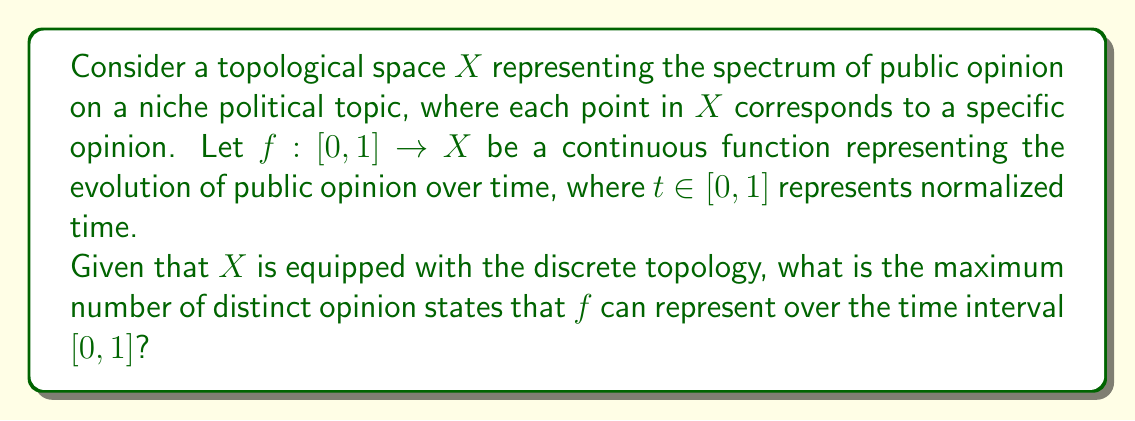Teach me how to tackle this problem. To solve this problem, we need to consider the properties of continuous functions and the discrete topology:

1) In the discrete topology, every subset of $X$ is both open and closed.

2) The function $f: [0, 1] \rightarrow X$ is continuous.

3) For a continuous function, the preimage of any open set in the codomain must be open in the domain.

4) $[0, 1]$ is a connected space in the standard topology.

5) The image of a connected space under a continuous function must be connected.

Given these properties:

a) If $f$ takes on more than one value, then its image would not be connected in the discrete topology of $X$.

b) This is because in the discrete topology, any two distinct points form a disconnected set.

c) However, the image of $f$ must be connected as $[0, 1]$ is connected and $f$ is continuous.

Therefore, $f$ must be constant over the entire interval $[0, 1]$. It can only represent a single opinion state throughout the time interval.

This result illustrates that in the context of the discrete topology, continuous changes in public opinion on niche political topics are mathematically impossible. In reality, public opinion often changes gradually, which would be better modeled using a different topology on $X$.
Answer: The maximum number of distinct opinion states that $f$ can represent over the time interval $[0, 1]$ is 1. 